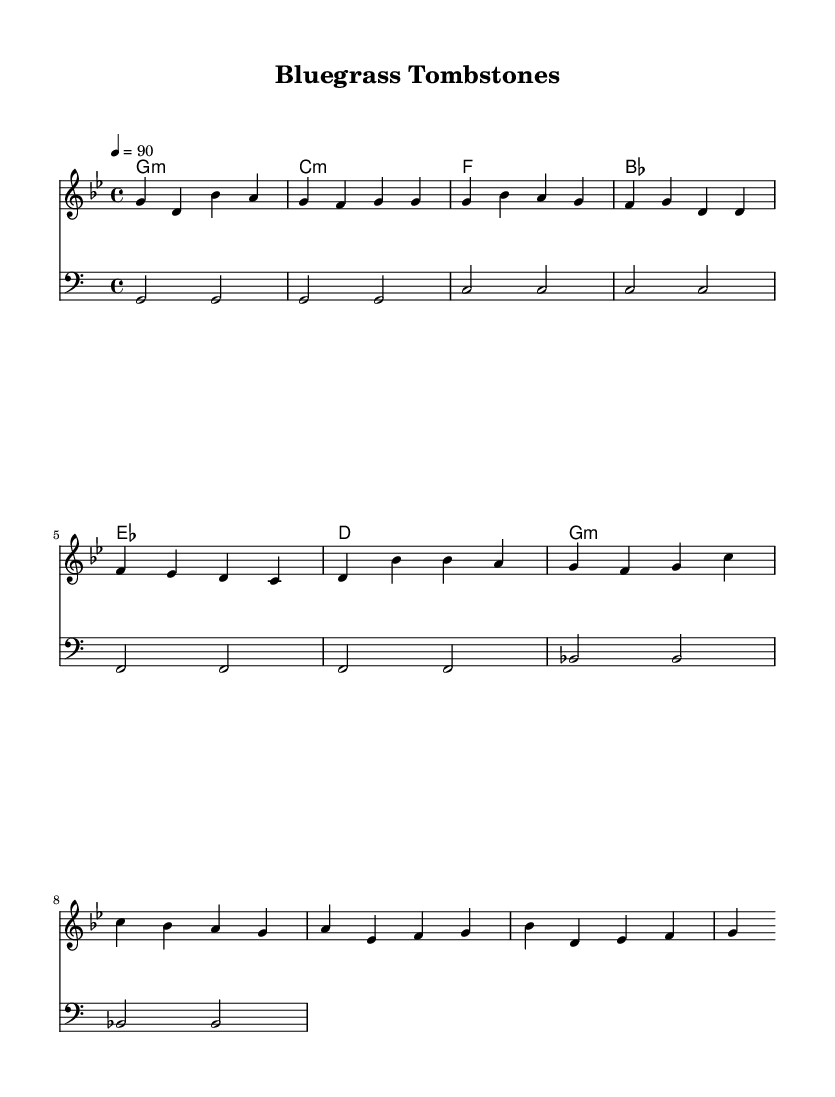What is the key signature of this music? The key signature indicated in the music is G minor, which has two flats: B♭ and E♭. This can be identified at the beginning of the staff, where sharps or flats are shown.
Answer: G minor What is the time signature of this music? The time signature displayed is 4/4, which means there are four beats in each measure, and the quarter note receives one beat. This is usually shown at the beginning of the piece.
Answer: 4/4 What is the tempo marking for this music? The tempo is indicated as 4 = 90, which means there are 90 quarter note beats per minute. This is typically found above the staff, signifying the speed of the piece.
Answer: 90 How many measures are there in the melody? By counting the melody notation provided, there are a total of 9 measures. This is calculated by identifying the vertical bar lines that indicate the end of each measure.
Answer: 9 What is the harmonic progression used in this music? The harmonic progression indicated by the chord symbols includes G minor, C minor, F, B♭, E♭, D, and back to G minor. This sequence guides the musical structure and tonality throughout the piece.
Answer: G minor, C minor, F, B♭, E♭, D, G minor What type of music does this piece represent? This piece represents hip hop music, characterized by its rhythmic lyrics and strong musical beat. The combination of the spoken narrative style or rap typically found in hip hop reflects local narratives and histories, including references to notable Kentucky cemeteries.
Answer: Hip hop 